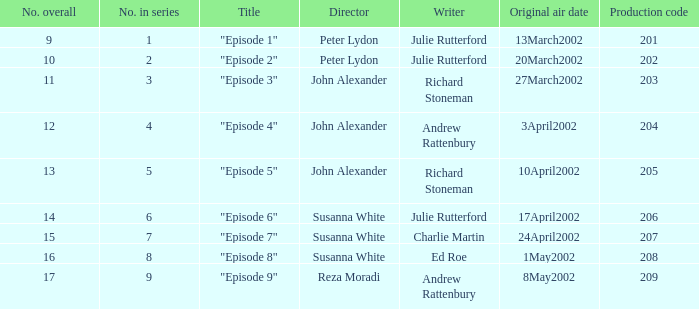When "episode 1" is the title what is the overall number? 9.0. 